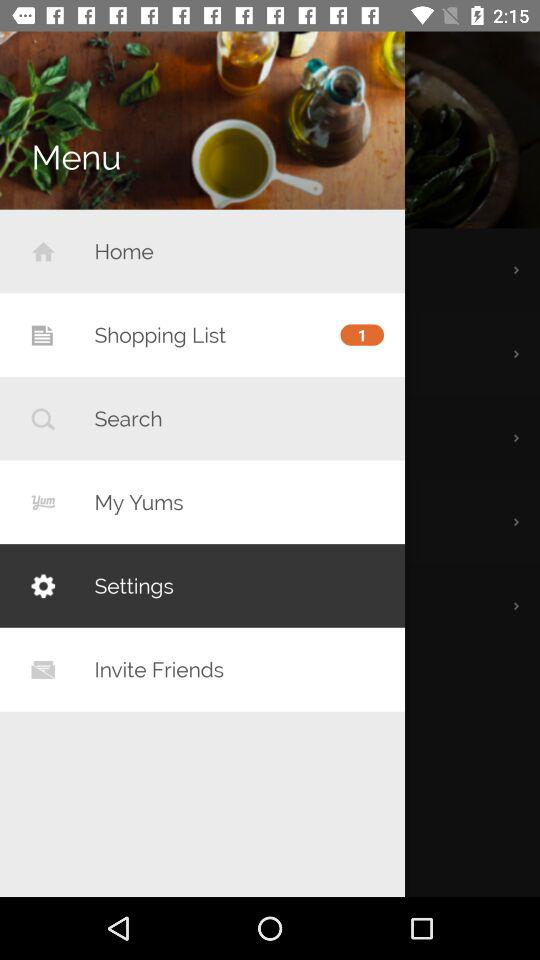Which is the selected item in the menu? The selected item is "Settings". 